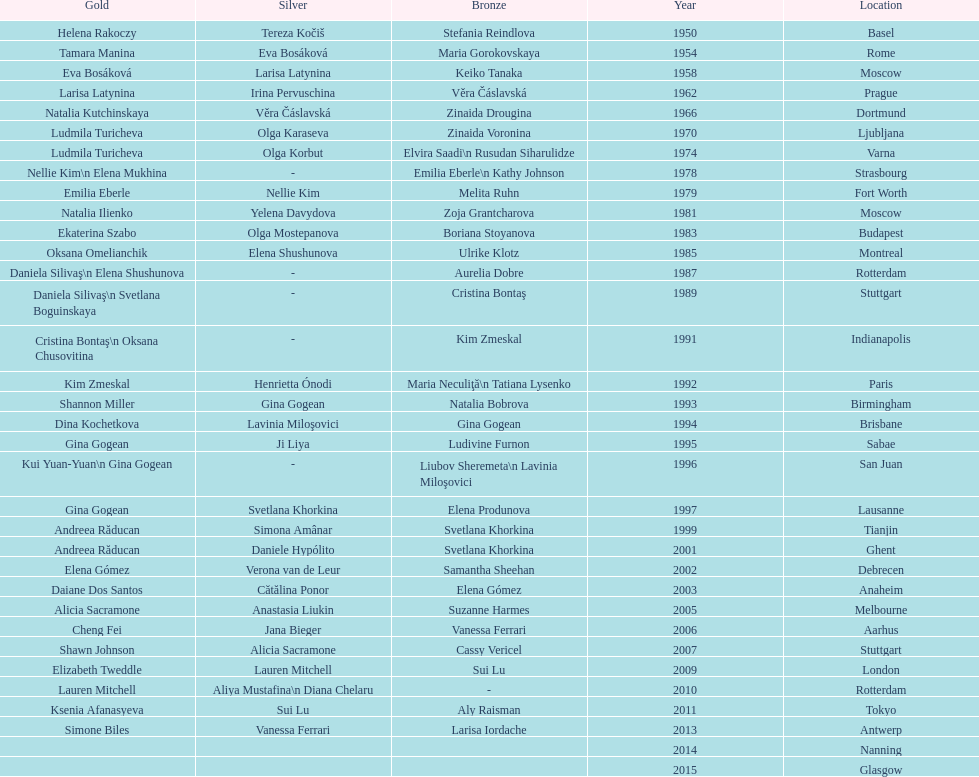As of 2013, what is the total number of floor exercise gold medals won by american women at the world championships? 5. Parse the full table. {'header': ['Gold', 'Silver', 'Bronze', 'Year', 'Location'], 'rows': [['Helena Rakoczy', 'Tereza Kočiš', 'Stefania Reindlova', '1950', 'Basel'], ['Tamara Manina', 'Eva Bosáková', 'Maria Gorokovskaya', '1954', 'Rome'], ['Eva Bosáková', 'Larisa Latynina', 'Keiko Tanaka', '1958', 'Moscow'], ['Larisa Latynina', 'Irina Pervuschina', 'Věra Čáslavská', '1962', 'Prague'], ['Natalia Kutchinskaya', 'Věra Čáslavská', 'Zinaida Drougina', '1966', 'Dortmund'], ['Ludmila Turicheva', 'Olga Karaseva', 'Zinaida Voronina', '1970', 'Ljubljana'], ['Ludmila Turicheva', 'Olga Korbut', 'Elvira Saadi\\n Rusudan Siharulidze', '1974', 'Varna'], ['Nellie Kim\\n Elena Mukhina', '-', 'Emilia Eberle\\n Kathy Johnson', '1978', 'Strasbourg'], ['Emilia Eberle', 'Nellie Kim', 'Melita Ruhn', '1979', 'Fort Worth'], ['Natalia Ilienko', 'Yelena Davydova', 'Zoja Grantcharova', '1981', 'Moscow'], ['Ekaterina Szabo', 'Olga Mostepanova', 'Boriana Stoyanova', '1983', 'Budapest'], ['Oksana Omelianchik', 'Elena Shushunova', 'Ulrike Klotz', '1985', 'Montreal'], ['Daniela Silivaş\\n Elena Shushunova', '-', 'Aurelia Dobre', '1987', 'Rotterdam'], ['Daniela Silivaş\\n Svetlana Boguinskaya', '-', 'Cristina Bontaş', '1989', 'Stuttgart'], ['Cristina Bontaş\\n Oksana Chusovitina', '-', 'Kim Zmeskal', '1991', 'Indianapolis'], ['Kim Zmeskal', 'Henrietta Ónodi', 'Maria Neculiţă\\n Tatiana Lysenko', '1992', 'Paris'], ['Shannon Miller', 'Gina Gogean', 'Natalia Bobrova', '1993', 'Birmingham'], ['Dina Kochetkova', 'Lavinia Miloşovici', 'Gina Gogean', '1994', 'Brisbane'], ['Gina Gogean', 'Ji Liya', 'Ludivine Furnon', '1995', 'Sabae'], ['Kui Yuan-Yuan\\n Gina Gogean', '-', 'Liubov Sheremeta\\n Lavinia Miloşovici', '1996', 'San Juan'], ['Gina Gogean', 'Svetlana Khorkina', 'Elena Produnova', '1997', 'Lausanne'], ['Andreea Răducan', 'Simona Amânar', 'Svetlana Khorkina', '1999', 'Tianjin'], ['Andreea Răducan', 'Daniele Hypólito', 'Svetlana Khorkina', '2001', 'Ghent'], ['Elena Gómez', 'Verona van de Leur', 'Samantha Sheehan', '2002', 'Debrecen'], ['Daiane Dos Santos', 'Cătălina Ponor', 'Elena Gómez', '2003', 'Anaheim'], ['Alicia Sacramone', 'Anastasia Liukin', 'Suzanne Harmes', '2005', 'Melbourne'], ['Cheng Fei', 'Jana Bieger', 'Vanessa Ferrari', '2006', 'Aarhus'], ['Shawn Johnson', 'Alicia Sacramone', 'Cassy Vericel', '2007', 'Stuttgart'], ['Elizabeth Tweddle', 'Lauren Mitchell', 'Sui Lu', '2009', 'London'], ['Lauren Mitchell', 'Aliya Mustafina\\n Diana Chelaru', '-', '2010', 'Rotterdam'], ['Ksenia Afanasyeva', 'Sui Lu', 'Aly Raisman', '2011', 'Tokyo'], ['Simone Biles', 'Vanessa Ferrari', 'Larisa Iordache', '2013', 'Antwerp'], ['', '', '', '2014', 'Nanning'], ['', '', '', '2015', 'Glasgow']]} 